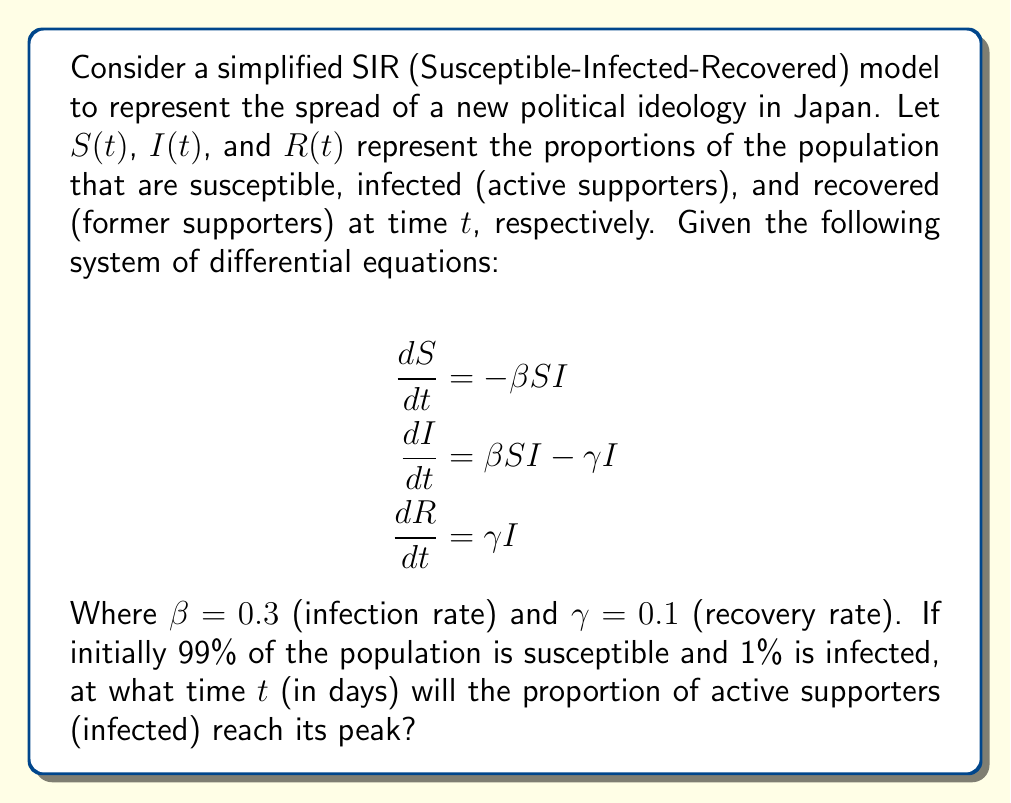Solve this math problem. To solve this problem, we need to follow these steps:

1) First, we need to understand that the peak of infection occurs when $\frac{dI}{dt} = 0$. At this point, the rate of new infections equals the rate of recovery.

2) From the second equation:

   $$\frac{dI}{dt} = \beta SI - \gamma I = 0$$

3) This implies:

   $$\beta SI = \gamma I$$
   $$S = \frac{\gamma}{\beta}$$

4) Substituting the given values:

   $$S = \frac{0.1}{0.3} = \frac{1}{3}$$

5) This means that when the infection peaks, one-third of the population will be susceptible.

6) Now, we need to find when $S(t) = \frac{1}{3}$. We can use the equation for $S(t)$:

   $$S(t) = S_0 e^{-\beta R(t)}$$

   Where $S_0 = 0.99$ (initial susceptible population)

7) At the peak, $S(t) = \frac{1}{3}$, so:

   $$\frac{1}{3} = 0.99 e^{-0.3 R(t)}$$

8) Solving for $R(t)$:

   $$R(t) = -\frac{1}{0.3} \ln(\frac{1}{3 \cdot 0.99}) \approx 3.619$$

9) Now, we can use the equation for $R(t)$:

   $$R(t) = 1 - S(t) - I(t)$$

   At $t=0$, $R(0) = 0$, $S(0) = 0.99$, $I(0) = 0.01$

10) The rate of change of $R$ is given by $\frac{dR}{dt} = \gamma I$. Assuming this rate is approximately constant until the peak, we can estimate the time to peak as:

    $$t \approx \frac{R(t)}{\gamma I(0)} = \frac{3.619}{0.1 \cdot 0.01} \approx 36.19$$

Therefore, the peak of active supporters will occur approximately 36.19 days after the introduction of the new political ideology.
Answer: 36.19 days 